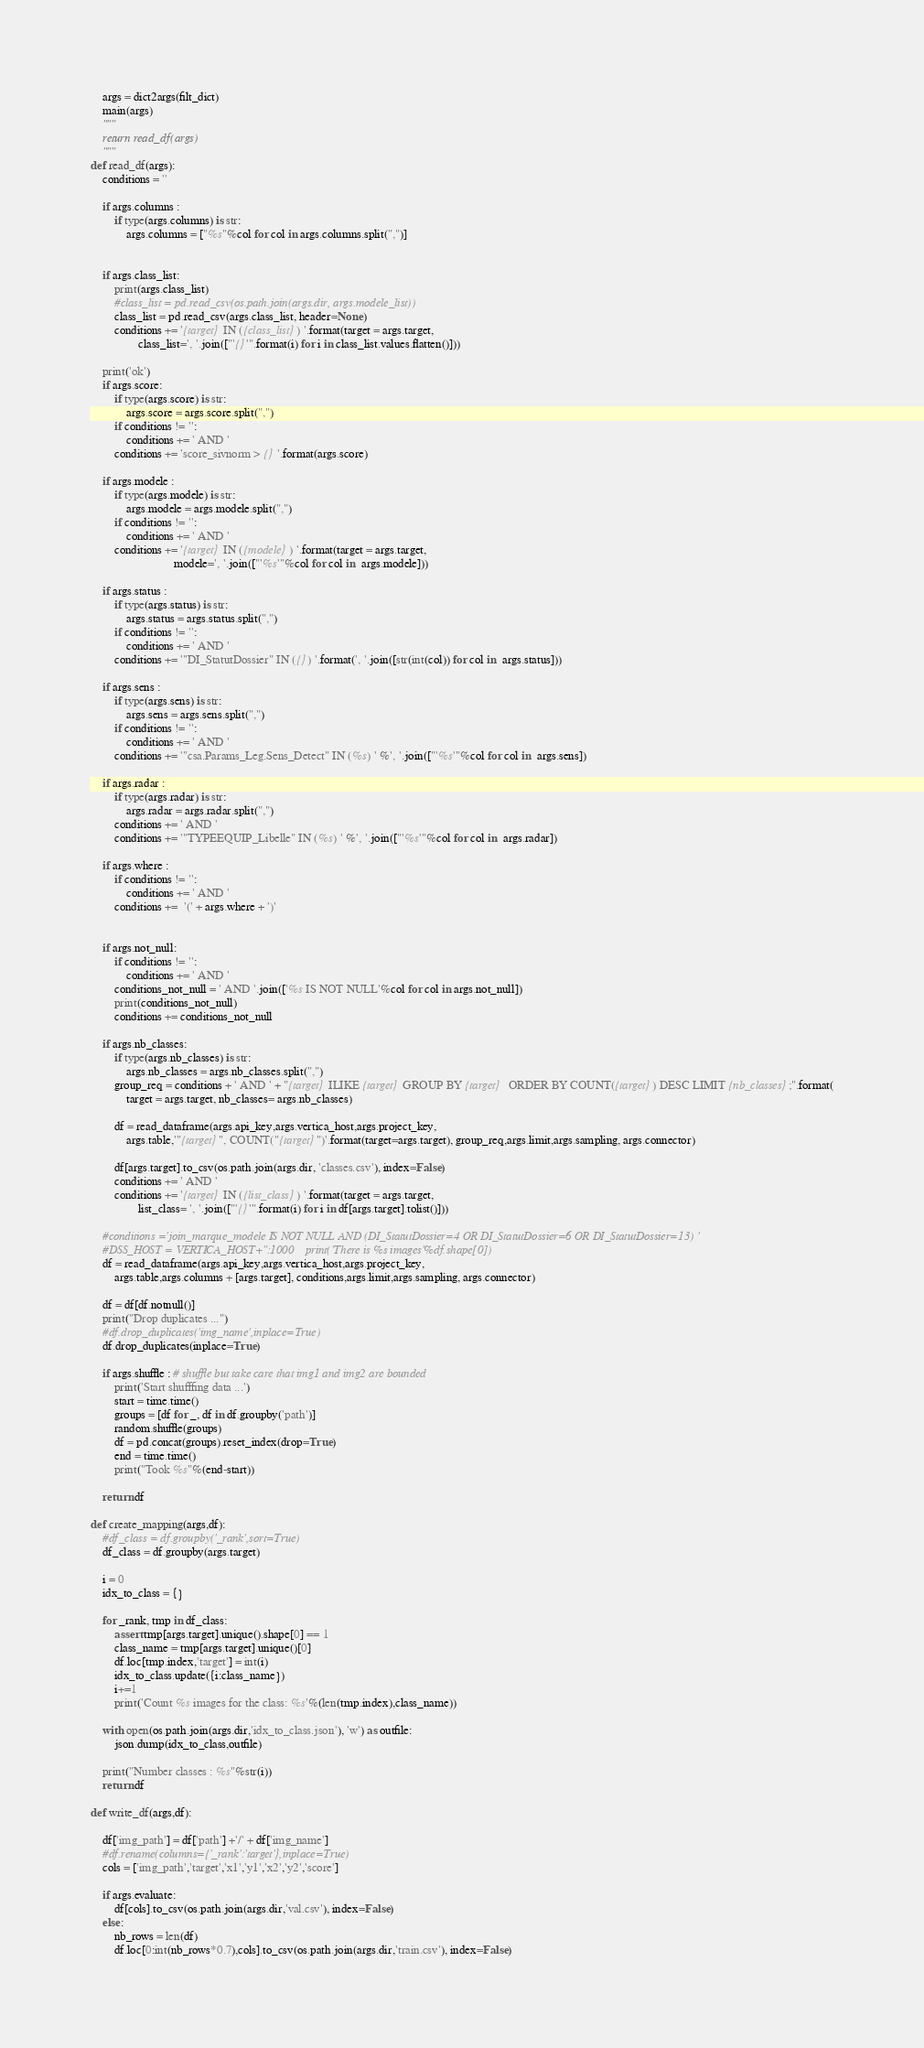Convert code to text. <code><loc_0><loc_0><loc_500><loc_500><_Python_>
    args = dict2args(filt_dict)
    main(args)
    """
    return read_df(args)
    """
def read_df(args):
    conditions = ''

    if args.columns :
        if type(args.columns) is str:
            args.columns = ["%s"%col for col in args.columns.split(",")]


    if args.class_list:
        print(args.class_list)
        #class_list = pd.read_csv(os.path.join(args.dir, args.modele_list))
        class_list = pd.read_csv(args.class_list, header=None)
        conditions += '{target} IN ({class_list}) '.format(target = args.target,
                class_list=', '.join(["'{}'".format(i) for i in class_list.values.flatten()]))

    print('ok')
    if args.score:
        if type(args.score) is str:
            args.score = args.score.split(",")
        if conditions != '':
            conditions += ' AND '
        conditions += 'score_sivnorm > {} '.format(args.score)

    if args.modele :
        if type(args.modele) is str:
            args.modele = args.modele.split(",")
        if conditions != '':
            conditions += ' AND '
        conditions += '{target} IN ({modele}) '.format(target = args.target,
                            modele=', '.join(["'%s'"%col for col in  args.modele]))

    if args.status :
        if type(args.status) is str:
            args.status = args.status.split(",")
        if conditions != '':
            conditions += ' AND '
        conditions += '"DI_StatutDossier" IN ({}) '.format(', '.join([str(int(col)) for col in  args.status]))

    if args.sens :
        if type(args.sens) is str:
            args.sens = args.sens.split(",")
        if conditions != '':
            conditions += ' AND '
        conditions += '"csa.Params_Leg.Sens_Detect" IN (%s) ' %', '.join(["'%s'"%col for col in  args.sens])

    if args.radar :
        if type(args.radar) is str:
            args.radar = args.radar.split(",")
        conditions += ' AND '
        conditions += '"TYPEEQUIP_Libelle" IN (%s) ' %', '.join(["'%s'"%col for col in  args.radar])

    if args.where :
        if conditions != '':
            conditions += ' AND '
        conditions +=  '(' + args.where + ')'


    if args.not_null:
        if conditions != '':
            conditions += ' AND '
        conditions_not_null = ' AND '.join(['%s IS NOT NULL'%col for col in args.not_null])
        print(conditions_not_null)
        conditions += conditions_not_null

    if args.nb_classes:
        if type(args.nb_classes) is str:
            args.nb_classes = args.nb_classes.split(",")
        group_req = conditions + ' AND ' + "{target} ILIKE {target} GROUP BY {target}  ORDER BY COUNT({target}) DESC LIMIT {nb_classes};".format(
            target = args.target, nb_classes= args.nb_classes)

        df = read_dataframe(args.api_key,args.vertica_host,args.project_key,
            args.table,'"{target}", COUNT("{target}")'.format(target=args.target), group_req,args.limit,args.sampling, args.connector)

        df[args.target].to_csv(os.path.join(args.dir, 'classes.csv'), index=False)
        conditions += ' AND '
        conditions += '{target} IN ({list_class}) '.format(target = args.target,
                list_class= ', '.join(["'{}'".format(i) for i in df[args.target].tolist()]))

    #conditions ='join_marque_modele IS NOT NULL AND (DI_StatutDossier=4 OR DI_StatutDossier=6 OR DI_StatutDossier=13) '
    #DSS_HOST = VERTICA_HOST+":1000    print('There is %s images'%df.shape[0])
    df = read_dataframe(args.api_key,args.vertica_host,args.project_key,
        args.table,args.columns + [args.target], conditions,args.limit,args.sampling, args.connector)

    df = df[df.notnull()]
    print("Drop duplicates ...")
    #df.drop_duplicates('img_name',inplace=True)
    df.drop_duplicates(inplace=True)

    if args.shuffle : # shuffle but take care that img1 and img2 are bounded
        print('Start shufffing data ...')
        start = time.time()
        groups = [df for _, df in df.groupby('path')]
        random.shuffle(groups)
        df = pd.concat(groups).reset_index(drop=True)
        end = time.time()
        print("Took %s"%(end-start))

    return df

def create_mapping(args,df):
    #df_class = df.groupby('_rank',sort=True)
    df_class = df.groupby(args.target)

    i = 0
    idx_to_class = {}

    for _rank, tmp in df_class:
        assert tmp[args.target].unique().shape[0] == 1
        class_name = tmp[args.target].unique()[0]
        df.loc[tmp.index,'target'] = int(i)
        idx_to_class.update({i:class_name})
        i+=1
        print('Count %s images for the class: %s'%(len(tmp.index),class_name))

    with open(os.path.join(args.dir,'idx_to_class.json'), 'w') as outfile:
        json.dump(idx_to_class,outfile)

    print("Number classes : %s"%str(i))
    return df

def write_df(args,df):

    df['img_path'] = df['path'] +'/' + df['img_name']
    #df.rename(columns={'_rank':'target'},inplace=True)
    cols = ['img_path','target','x1','y1','x2','y2','score']

    if args.evaluate:
        df[cols].to_csv(os.path.join(args.dir,'val.csv'), index=False)
    else:
        nb_rows = len(df)
        df.loc[0:int(nb_rows*0.7),cols].to_csv(os.path.join(args.dir,'train.csv'), index=False)</code> 